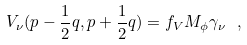<formula> <loc_0><loc_0><loc_500><loc_500>V _ { \nu } ( p - \frac { 1 } { 2 } q , p + \frac { 1 } { 2 } q ) = f _ { V } M _ { \phi } \gamma _ { \nu } \ ,</formula> 